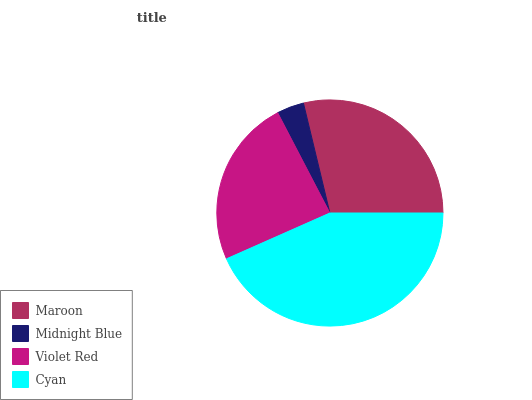Is Midnight Blue the minimum?
Answer yes or no. Yes. Is Cyan the maximum?
Answer yes or no. Yes. Is Violet Red the minimum?
Answer yes or no. No. Is Violet Red the maximum?
Answer yes or no. No. Is Violet Red greater than Midnight Blue?
Answer yes or no. Yes. Is Midnight Blue less than Violet Red?
Answer yes or no. Yes. Is Midnight Blue greater than Violet Red?
Answer yes or no. No. Is Violet Red less than Midnight Blue?
Answer yes or no. No. Is Maroon the high median?
Answer yes or no. Yes. Is Violet Red the low median?
Answer yes or no. Yes. Is Cyan the high median?
Answer yes or no. No. Is Midnight Blue the low median?
Answer yes or no. No. 